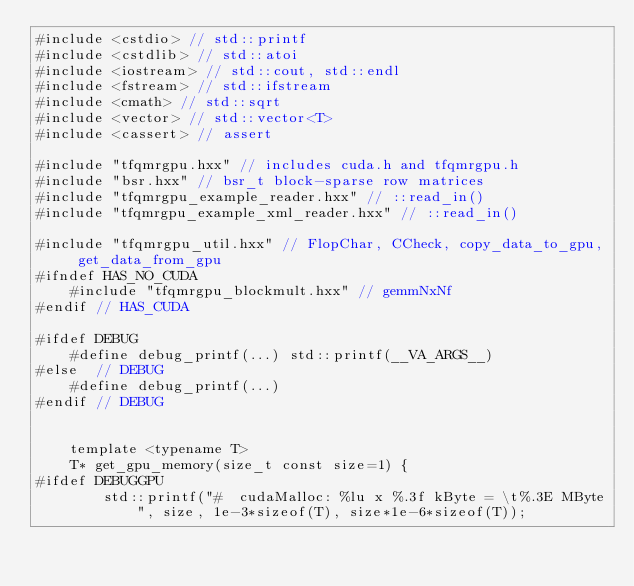Convert code to text. <code><loc_0><loc_0><loc_500><loc_500><_Cuda_>#include <cstdio> // std::printf
#include <cstdlib> // std::atoi
#include <iostream> // std::cout, std::endl
#include <fstream> // std::ifstream
#include <cmath> // std::sqrt
#include <vector> // std::vector<T>
#include <cassert> // assert

#include "tfqmrgpu.hxx" // includes cuda.h and tfqmrgpu.h
#include "bsr.hxx" // bsr_t block-sparse row matrices
#include "tfqmrgpu_example_reader.hxx" // ::read_in()
#include "tfqmrgpu_example_xml_reader.hxx" // ::read_in()

#include "tfqmrgpu_util.hxx" // FlopChar, CCheck, copy_data_to_gpu, get_data_from_gpu
#ifndef HAS_NO_CUDA
    #include "tfqmrgpu_blockmult.hxx" // gemmNxNf
#endif // HAS_CUDA

#ifdef DEBUG
    #define debug_printf(...) std::printf(__VA_ARGS__)
#else  // DEBUG
    #define debug_printf(...)
#endif // DEBUG


    template <typename T>
    T* get_gpu_memory(size_t const size=1) {
#ifdef DEBUGGPU
        std::printf("#  cudaMalloc: %lu x %.3f kByte = \t%.3E MByte", size, 1e-3*sizeof(T), size*1e-6*sizeof(T));</code> 